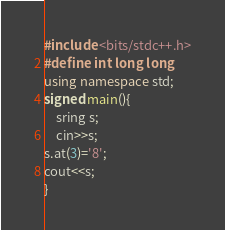Convert code to text. <code><loc_0><loc_0><loc_500><loc_500><_C++_>#include <bits/stdc++.h>
#define int long long
using namespace std;
signed main(){
	sring s;
	cin>>s;
s.at(3)='8';
cout<<s;
}</code> 